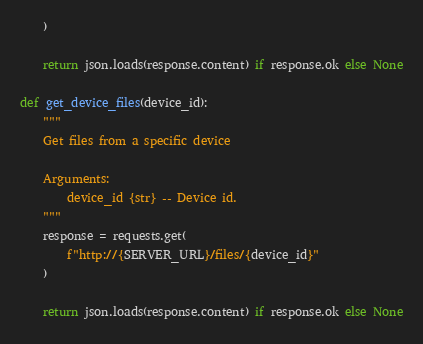<code> <loc_0><loc_0><loc_500><loc_500><_Python_>    )

    return json.loads(response.content) if response.ok else None

def get_device_files(device_id):
    """
    Get files from a specific device

    Arguments:
        device_id {str} -- Device id.
    """
    response = requests.get(
        f"http://{SERVER_URL}/files/{device_id}"
    )

    return json.loads(response.content) if response.ok else None

</code> 